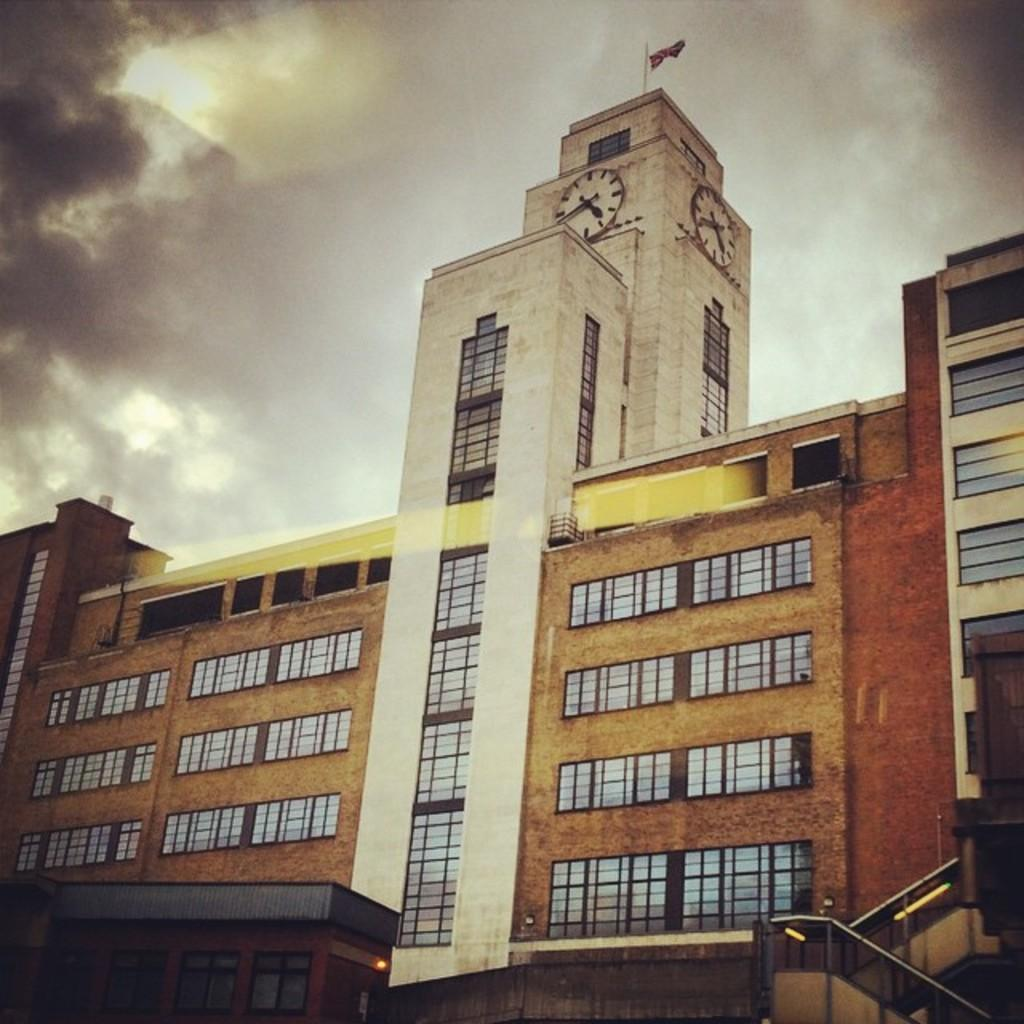What structures can be seen in the image? There are buildings in the image. What part of the natural environment is visible in the image? The sky is visible in the background of the image. How many babies are present at the meeting in the image? There is no meeting or babies present in the image; it features buildings and the sky. 